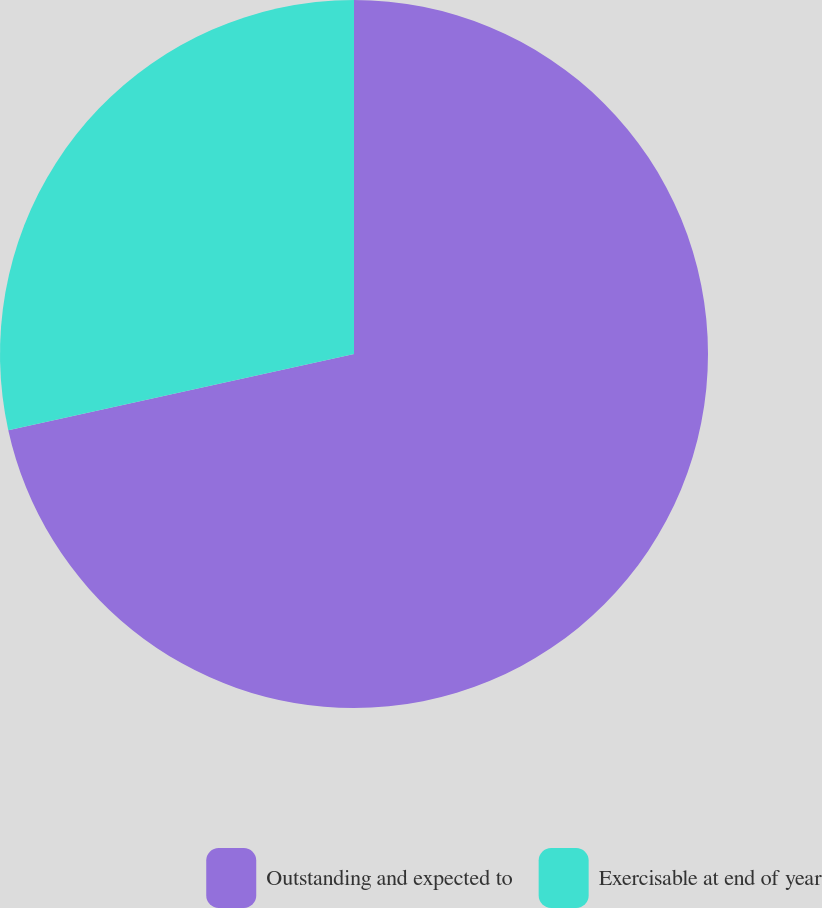<chart> <loc_0><loc_0><loc_500><loc_500><pie_chart><fcel>Outstanding and expected to<fcel>Exercisable at end of year<nl><fcel>71.55%<fcel>28.45%<nl></chart> 